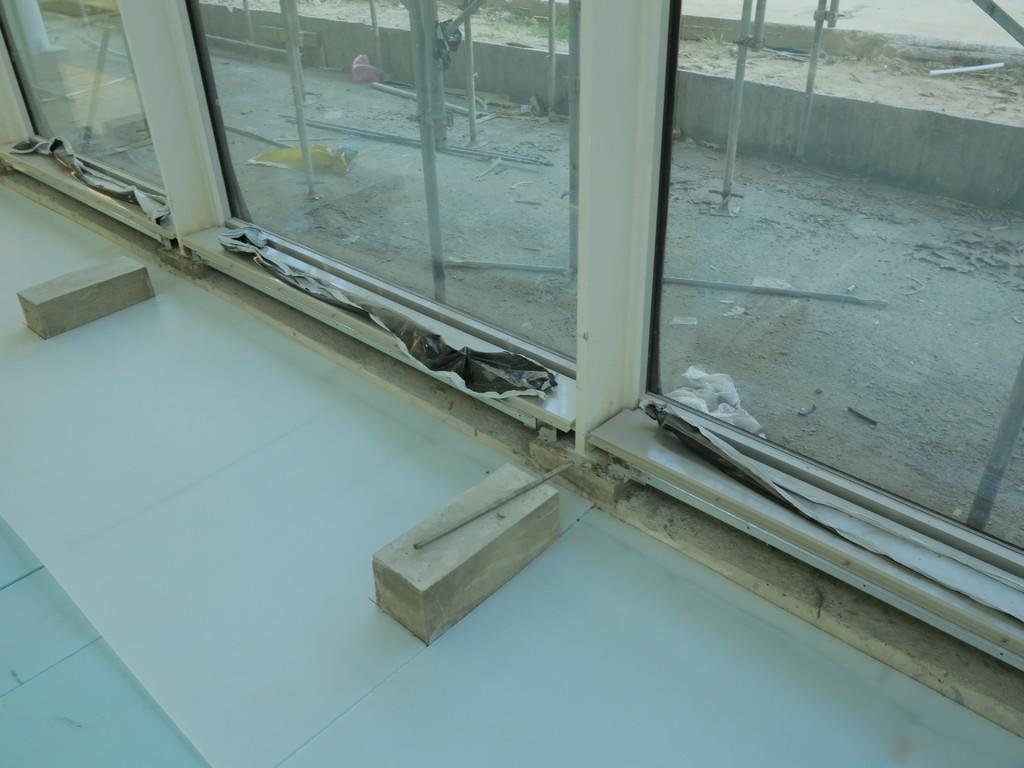In one or two sentences, can you explain what this image depicts? This image is taken indoors. At the bottom of the image there is a floor. In the middle of the image there are two bricks on the floor. In the background there is a glass door, through the glass door we can see there are a few wooden sticks and there is a ground. 